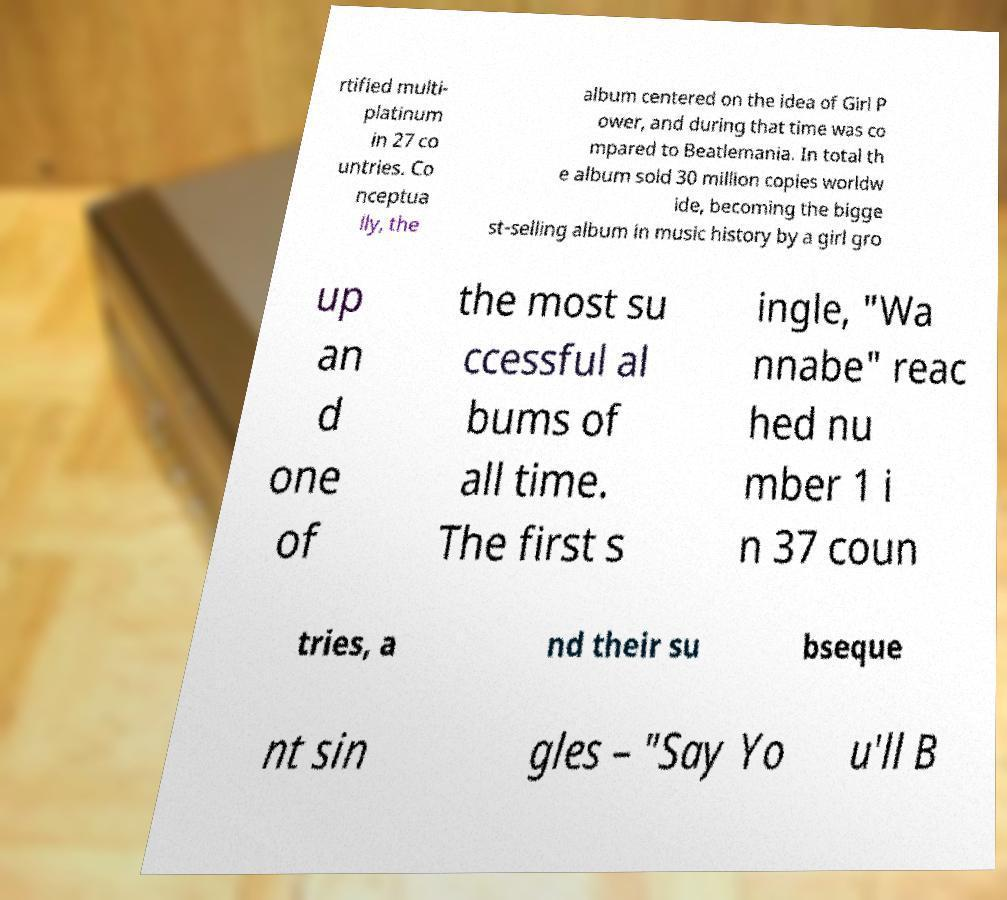Could you extract and type out the text from this image? rtified multi- platinum in 27 co untries. Co nceptua lly, the album centered on the idea of Girl P ower, and during that time was co mpared to Beatlemania. In total th e album sold 30 million copies worldw ide, becoming the bigge st-selling album in music history by a girl gro up an d one of the most su ccessful al bums of all time. The first s ingle, "Wa nnabe" reac hed nu mber 1 i n 37 coun tries, a nd their su bseque nt sin gles – "Say Yo u'll B 